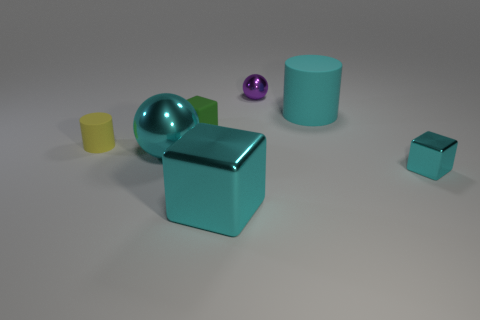Subtract all cyan blocks. Subtract all green cylinders. How many blocks are left? 1 Add 1 large metal spheres. How many objects exist? 8 Subtract all blocks. How many objects are left? 4 Add 2 big green matte things. How many big green matte things exist? 2 Subtract 0 purple cylinders. How many objects are left? 7 Subtract all brown metallic cubes. Subtract all metal balls. How many objects are left? 5 Add 7 tiny matte cubes. How many tiny matte cubes are left? 8 